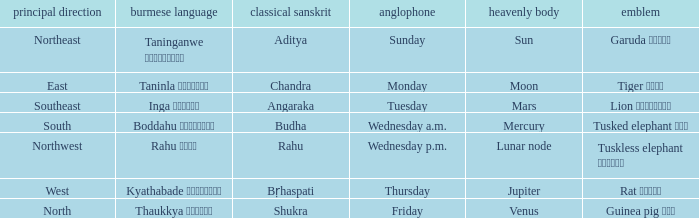What is the Burmese term associated with a cardinal direction of west? Kyathabade ကြာသပတေး. 